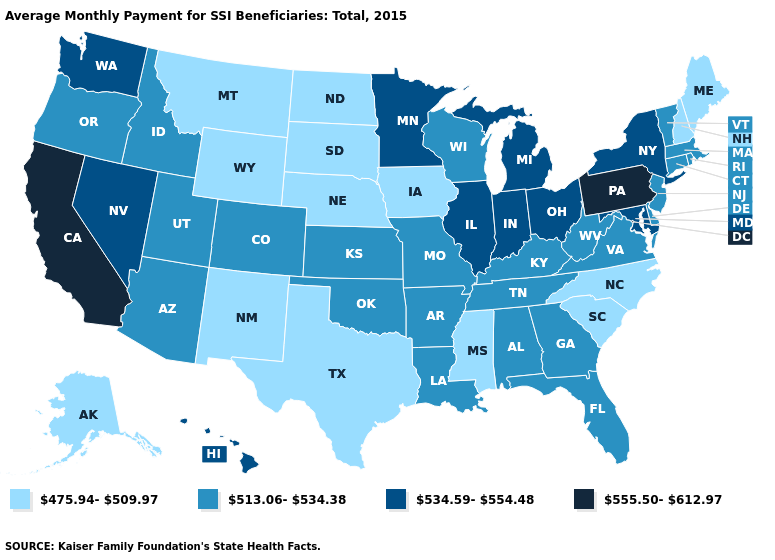What is the value of Colorado?
Concise answer only. 513.06-534.38. Name the states that have a value in the range 475.94-509.97?
Keep it brief. Alaska, Iowa, Maine, Mississippi, Montana, Nebraska, New Hampshire, New Mexico, North Carolina, North Dakota, South Carolina, South Dakota, Texas, Wyoming. What is the value of Utah?
Concise answer only. 513.06-534.38. Does California have the highest value in the West?
Concise answer only. Yes. Which states have the lowest value in the West?
Short answer required. Alaska, Montana, New Mexico, Wyoming. Name the states that have a value in the range 534.59-554.48?
Quick response, please. Hawaii, Illinois, Indiana, Maryland, Michigan, Minnesota, Nevada, New York, Ohio, Washington. Name the states that have a value in the range 555.50-612.97?
Keep it brief. California, Pennsylvania. Name the states that have a value in the range 555.50-612.97?
Answer briefly. California, Pennsylvania. Does Iowa have the lowest value in the USA?
Answer briefly. Yes. What is the value of Georgia?
Give a very brief answer. 513.06-534.38. Name the states that have a value in the range 534.59-554.48?
Answer briefly. Hawaii, Illinois, Indiana, Maryland, Michigan, Minnesota, Nevada, New York, Ohio, Washington. Among the states that border Rhode Island , which have the highest value?
Keep it brief. Connecticut, Massachusetts. Which states have the lowest value in the USA?
Be succinct. Alaska, Iowa, Maine, Mississippi, Montana, Nebraska, New Hampshire, New Mexico, North Carolina, North Dakota, South Carolina, South Dakota, Texas, Wyoming. Does Georgia have the lowest value in the South?
Write a very short answer. No. Is the legend a continuous bar?
Short answer required. No. 